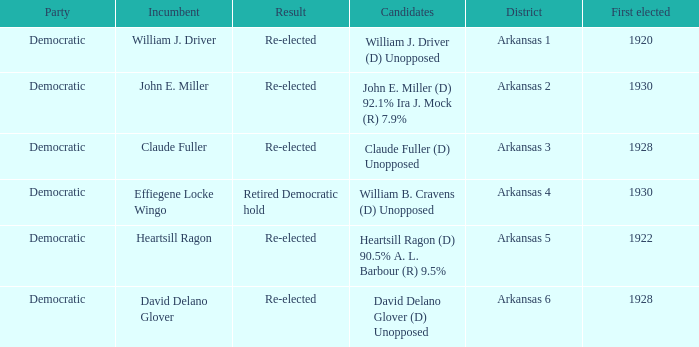What year was incumbent Claude Fuller first elected?  1928.0. 